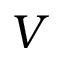Convert formula to latex. <formula><loc_0><loc_0><loc_500><loc_500>V</formula> 